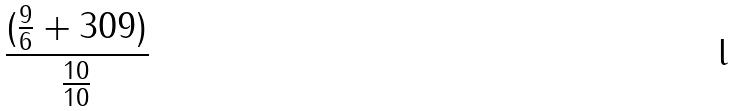<formula> <loc_0><loc_0><loc_500><loc_500>\frac { ( \frac { 9 } { 6 } + 3 0 9 ) } { \frac { 1 0 } { 1 0 } }</formula> 